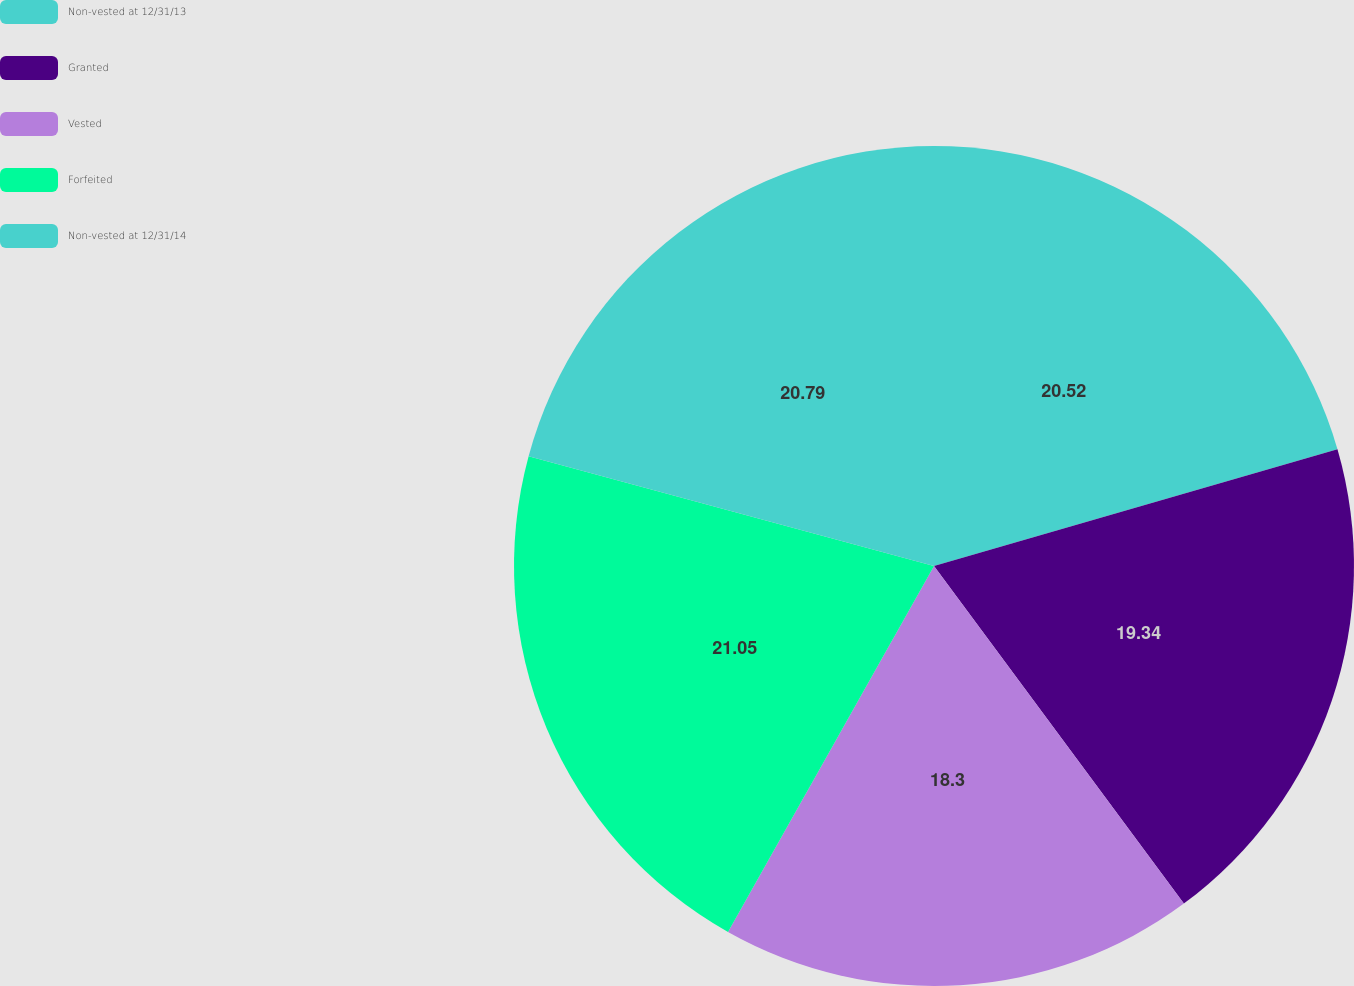Convert chart. <chart><loc_0><loc_0><loc_500><loc_500><pie_chart><fcel>Non-vested at 12/31/13<fcel>Granted<fcel>Vested<fcel>Forfeited<fcel>Non-vested at 12/31/14<nl><fcel>20.52%<fcel>19.34%<fcel>18.3%<fcel>21.05%<fcel>20.79%<nl></chart> 